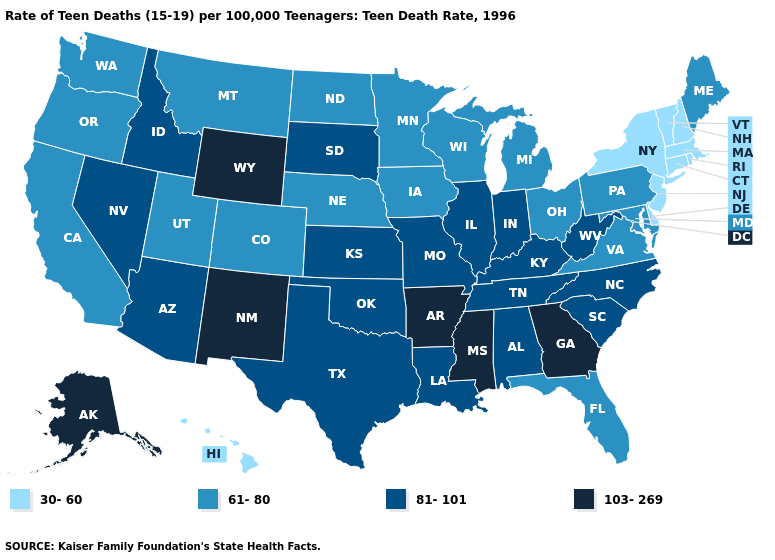Among the states that border Michigan , which have the lowest value?
Write a very short answer. Ohio, Wisconsin. Name the states that have a value in the range 30-60?
Give a very brief answer. Connecticut, Delaware, Hawaii, Massachusetts, New Hampshire, New Jersey, New York, Rhode Island, Vermont. Which states have the highest value in the USA?
Concise answer only. Alaska, Arkansas, Georgia, Mississippi, New Mexico, Wyoming. What is the lowest value in states that border Massachusetts?
Write a very short answer. 30-60. How many symbols are there in the legend?
Concise answer only. 4. Name the states that have a value in the range 30-60?
Concise answer only. Connecticut, Delaware, Hawaii, Massachusetts, New Hampshire, New Jersey, New York, Rhode Island, Vermont. Name the states that have a value in the range 81-101?
Concise answer only. Alabama, Arizona, Idaho, Illinois, Indiana, Kansas, Kentucky, Louisiana, Missouri, Nevada, North Carolina, Oklahoma, South Carolina, South Dakota, Tennessee, Texas, West Virginia. Name the states that have a value in the range 81-101?
Concise answer only. Alabama, Arizona, Idaho, Illinois, Indiana, Kansas, Kentucky, Louisiana, Missouri, Nevada, North Carolina, Oklahoma, South Carolina, South Dakota, Tennessee, Texas, West Virginia. What is the highest value in the USA?
Quick response, please. 103-269. Does Illinois have the lowest value in the MidWest?
Short answer required. No. Name the states that have a value in the range 103-269?
Give a very brief answer. Alaska, Arkansas, Georgia, Mississippi, New Mexico, Wyoming. What is the lowest value in the USA?
Quick response, please. 30-60. Name the states that have a value in the range 61-80?
Concise answer only. California, Colorado, Florida, Iowa, Maine, Maryland, Michigan, Minnesota, Montana, Nebraska, North Dakota, Ohio, Oregon, Pennsylvania, Utah, Virginia, Washington, Wisconsin. Does Idaho have a higher value than Pennsylvania?
Answer briefly. Yes. What is the value of Wyoming?
Answer briefly. 103-269. 